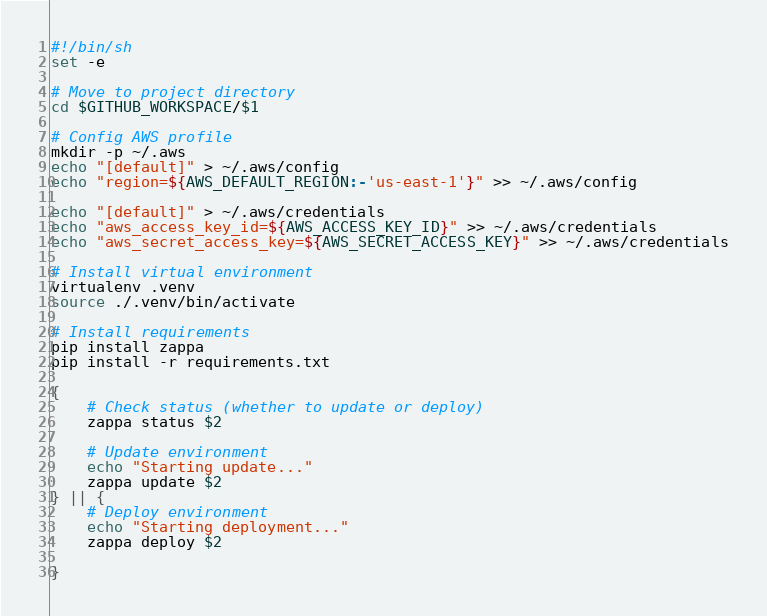<code> <loc_0><loc_0><loc_500><loc_500><_Bash_>#!/bin/sh
set -e

# Move to project directory
cd $GITHUB_WORKSPACE/$1

# Config AWS profile
mkdir -p ~/.aws
echo "[default]" > ~/.aws/config
echo "region=${AWS_DEFAULT_REGION:-'us-east-1'}" >> ~/.aws/config

echo "[default]" > ~/.aws/credentials
echo "aws_access_key_id=${AWS_ACCESS_KEY_ID}" >> ~/.aws/credentials
echo "aws_secret_access_key=${AWS_SECRET_ACCESS_KEY}" >> ~/.aws/credentials

# Install virtual environment
virtualenv .venv
source ./.venv/bin/activate

# Install requirements
pip install zappa
pip install -r requirements.txt

{
    # Check status (whether to update or deploy)
    zappa status $2

    # Update environment
    echo "Starting update..."
    zappa update $2
} || {
    # Deploy environment
    echo "Starting deployment..."
    zappa deploy $2
   
}</code> 